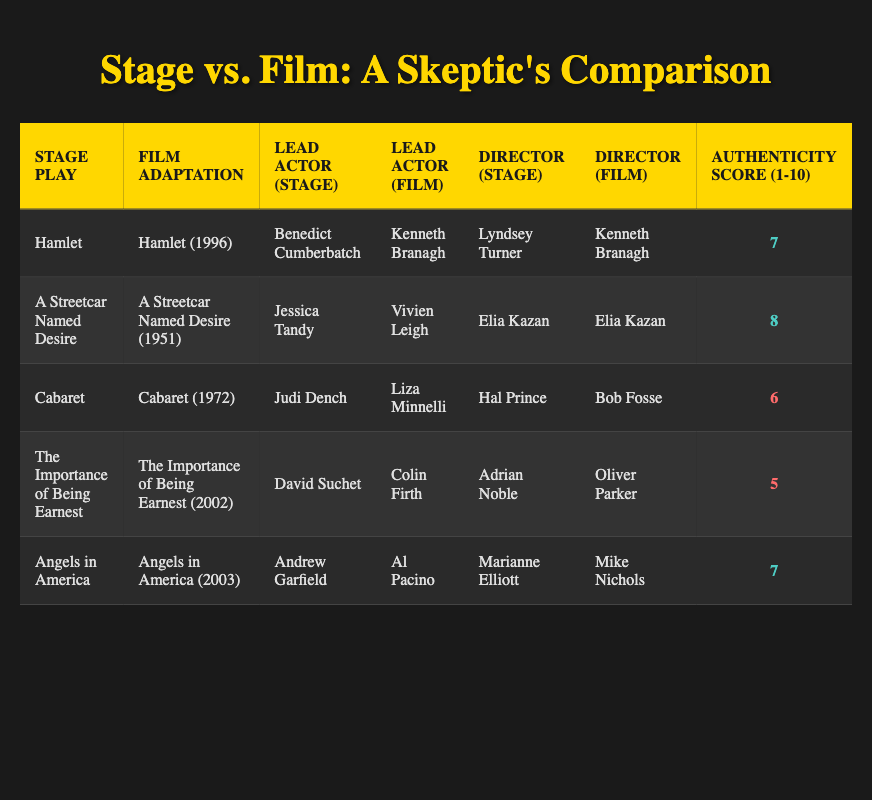What is the authenticity score of "The Importance of Being Earnest"? From the table, I can find "The Importance of Being Earnest" in the row for that play, which shows an authenticity score of 5.
Answer: 5 Who directed the film adaptation of "A Streetcar Named Desire"? Looking at the row for "A Streetcar Named Desire," the director in the Film Adaptation column is Elia Kazan.
Answer: Elia Kazan Which lead actor has the highest authenticity score and in which play? To find this, I can compare the authenticity scores from each row. The highest score is 8 for "A Streetcar Named Desire."
Answer: A Streetcar Named Desire, 8 Is the lead actor in the stage play "Cabaret" different from that in its film adaptation? From the table, I see that the lead actor for the stage play "Cabaret" is Judi Dench while the film adaptation features Liza Minnelli. Since these names are different, the answer is yes.
Answer: Yes What is the average authenticity score for the stage plays in this comparison? I will add up all the authenticity scores: 7 + 8 + 6 + 5 + 7 = 33. Since there are 5 stage plays, I divide 33 by 5, resulting in an average score of 6.6.
Answer: 6.6 Which stage play has a higher authenticity score: "Angels in America" or "Hamlet"? Looking at the authenticity scores in the table, "Angels in America" has a score of 7, while "Hamlet" has a score of 7 as well. Therefore, both have equal scores.
Answer: Equal What is the difference in authenticity scores between the stage play "Cabaret" and its film adaptation? The authenticity score for "Cabaret" is 6, while there is no score provided for the film adaptation. Thus, it's impossible to calculate a difference based on available data. Therefore, the difference is moot.
Answer: N/A Which play has a lead actor in the stage adaptation that is also the same for the film adaptation? "A Streetcar Named Desire" is the only play where the lead actor in both adaptations is the same, as both were directed by Elia Kazan. However, the actor details differ (Jessica Tandy for stage, Vivien Leigh for film). Hence, there is no play with a matching lead actor.
Answer: N/A 